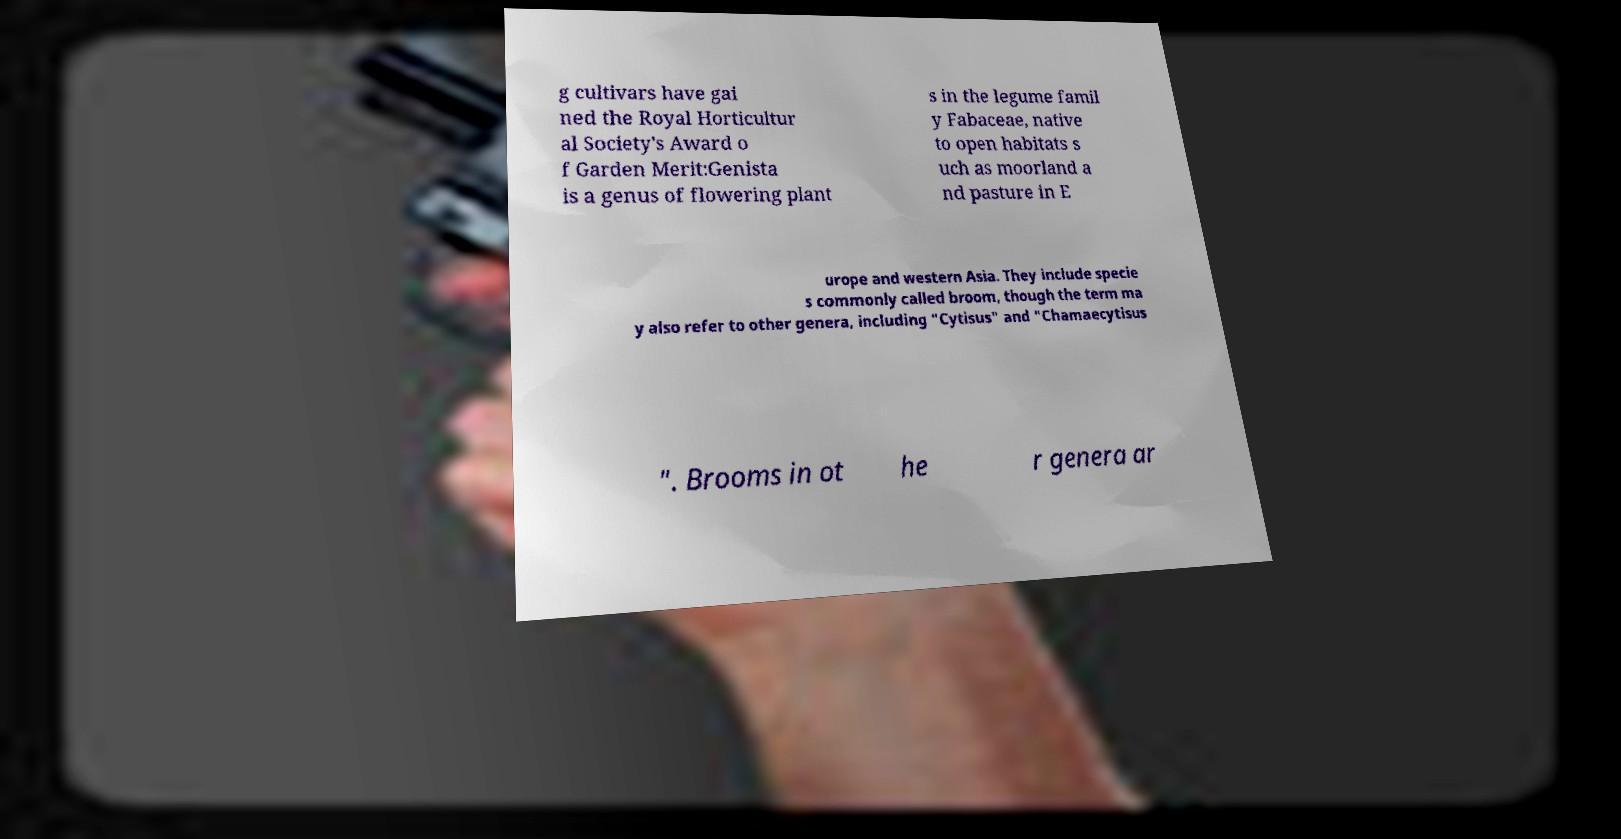Could you assist in decoding the text presented in this image and type it out clearly? g cultivars have gai ned the Royal Horticultur al Society's Award o f Garden Merit:Genista is a genus of flowering plant s in the legume famil y Fabaceae, native to open habitats s uch as moorland a nd pasture in E urope and western Asia. They include specie s commonly called broom, though the term ma y also refer to other genera, including "Cytisus" and "Chamaecytisus ". Brooms in ot he r genera ar 